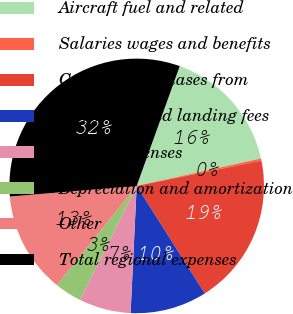<chart> <loc_0><loc_0><loc_500><loc_500><pie_chart><fcel>Aircraft fuel and related<fcel>Salaries wages and benefits<fcel>Capacity purchases from<fcel>Other rent and landing fees<fcel>Selling expenses<fcel>Depreciation and amortization<fcel>Other<fcel>Total regional expenses<nl><fcel>16.05%<fcel>0.28%<fcel>19.2%<fcel>9.74%<fcel>6.59%<fcel>3.43%<fcel>12.89%<fcel>31.82%<nl></chart> 